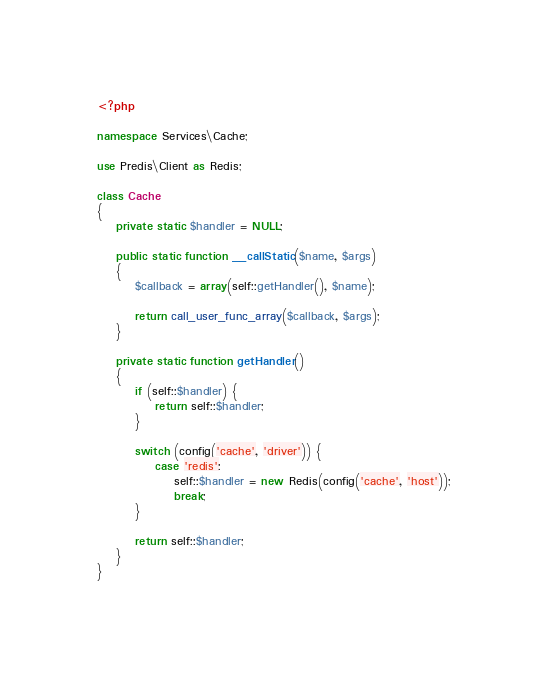Convert code to text. <code><loc_0><loc_0><loc_500><loc_500><_PHP_><?php

namespace Services\Cache;

use Predis\Client as Redis;

class Cache
{
    private static $handler = NULL;

    public static function __callStatic($name, $args)
    {
        $callback = array(self::getHandler(), $name);

        return call_user_func_array($callback, $args);
    }

    private static function getHandler()
    {
        if (self::$handler) {
            return self::$handler;
        }
    
        switch (config('cache', 'driver')) {
            case 'redis':
                self::$handler = new Redis(config('cache', 'host'));
                break;
        }

        return self::$handler;
    }
}</code> 